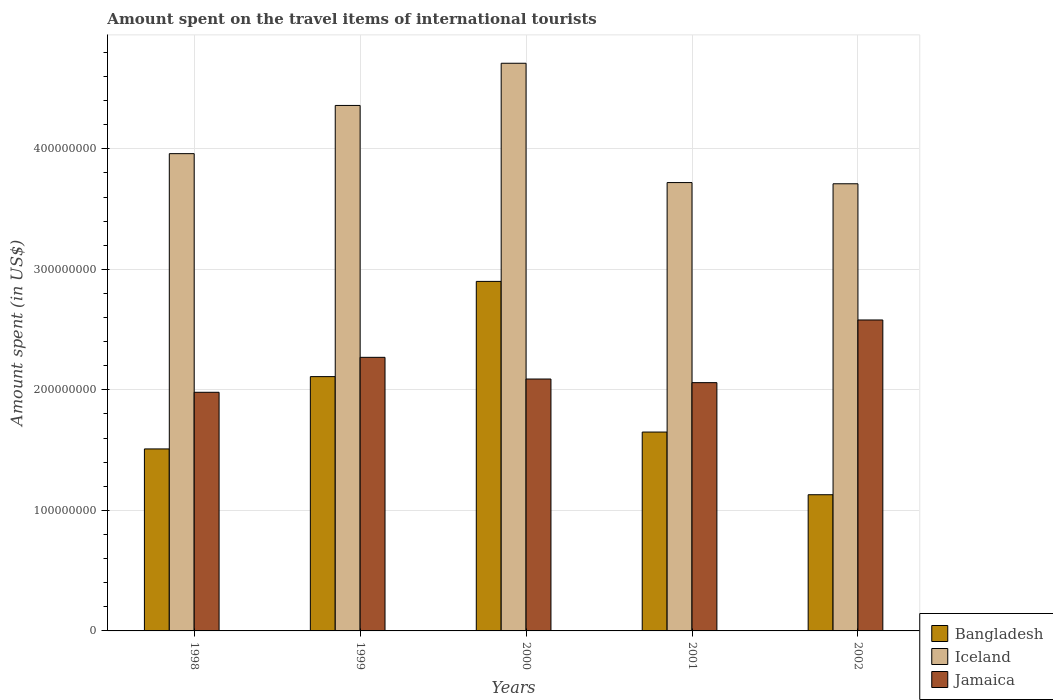How many different coloured bars are there?
Make the answer very short. 3. How many bars are there on the 4th tick from the right?
Provide a short and direct response. 3. What is the amount spent on the travel items of international tourists in Jamaica in 1999?
Give a very brief answer. 2.27e+08. Across all years, what is the maximum amount spent on the travel items of international tourists in Jamaica?
Keep it short and to the point. 2.58e+08. Across all years, what is the minimum amount spent on the travel items of international tourists in Jamaica?
Keep it short and to the point. 1.98e+08. In which year was the amount spent on the travel items of international tourists in Iceland maximum?
Your answer should be very brief. 2000. In which year was the amount spent on the travel items of international tourists in Bangladesh minimum?
Your answer should be very brief. 2002. What is the total amount spent on the travel items of international tourists in Jamaica in the graph?
Provide a short and direct response. 1.10e+09. What is the difference between the amount spent on the travel items of international tourists in Iceland in 2000 and that in 2002?
Keep it short and to the point. 1.00e+08. What is the difference between the amount spent on the travel items of international tourists in Iceland in 1998 and the amount spent on the travel items of international tourists in Jamaica in 1999?
Offer a very short reply. 1.69e+08. What is the average amount spent on the travel items of international tourists in Jamaica per year?
Your answer should be compact. 2.20e+08. In the year 2001, what is the difference between the amount spent on the travel items of international tourists in Bangladesh and amount spent on the travel items of international tourists in Iceland?
Keep it short and to the point. -2.07e+08. What is the ratio of the amount spent on the travel items of international tourists in Iceland in 1998 to that in 1999?
Your response must be concise. 0.91. What is the difference between the highest and the second highest amount spent on the travel items of international tourists in Bangladesh?
Your answer should be compact. 7.90e+07. What is the difference between the highest and the lowest amount spent on the travel items of international tourists in Iceland?
Your response must be concise. 1.00e+08. In how many years, is the amount spent on the travel items of international tourists in Bangladesh greater than the average amount spent on the travel items of international tourists in Bangladesh taken over all years?
Your response must be concise. 2. What does the 3rd bar from the left in 2001 represents?
Offer a very short reply. Jamaica. How many years are there in the graph?
Make the answer very short. 5. How many legend labels are there?
Keep it short and to the point. 3. What is the title of the graph?
Give a very brief answer. Amount spent on the travel items of international tourists. Does "Korea (Democratic)" appear as one of the legend labels in the graph?
Your answer should be compact. No. What is the label or title of the Y-axis?
Provide a succinct answer. Amount spent (in US$). What is the Amount spent (in US$) in Bangladesh in 1998?
Ensure brevity in your answer.  1.51e+08. What is the Amount spent (in US$) in Iceland in 1998?
Your answer should be compact. 3.96e+08. What is the Amount spent (in US$) in Jamaica in 1998?
Offer a terse response. 1.98e+08. What is the Amount spent (in US$) in Bangladesh in 1999?
Keep it short and to the point. 2.11e+08. What is the Amount spent (in US$) in Iceland in 1999?
Your answer should be compact. 4.36e+08. What is the Amount spent (in US$) of Jamaica in 1999?
Provide a short and direct response. 2.27e+08. What is the Amount spent (in US$) of Bangladesh in 2000?
Give a very brief answer. 2.90e+08. What is the Amount spent (in US$) in Iceland in 2000?
Your answer should be very brief. 4.71e+08. What is the Amount spent (in US$) of Jamaica in 2000?
Offer a very short reply. 2.09e+08. What is the Amount spent (in US$) of Bangladesh in 2001?
Provide a short and direct response. 1.65e+08. What is the Amount spent (in US$) of Iceland in 2001?
Keep it short and to the point. 3.72e+08. What is the Amount spent (in US$) of Jamaica in 2001?
Your answer should be compact. 2.06e+08. What is the Amount spent (in US$) in Bangladesh in 2002?
Provide a succinct answer. 1.13e+08. What is the Amount spent (in US$) in Iceland in 2002?
Keep it short and to the point. 3.71e+08. What is the Amount spent (in US$) in Jamaica in 2002?
Give a very brief answer. 2.58e+08. Across all years, what is the maximum Amount spent (in US$) in Bangladesh?
Ensure brevity in your answer.  2.90e+08. Across all years, what is the maximum Amount spent (in US$) in Iceland?
Offer a terse response. 4.71e+08. Across all years, what is the maximum Amount spent (in US$) of Jamaica?
Make the answer very short. 2.58e+08. Across all years, what is the minimum Amount spent (in US$) of Bangladesh?
Your answer should be compact. 1.13e+08. Across all years, what is the minimum Amount spent (in US$) of Iceland?
Offer a terse response. 3.71e+08. Across all years, what is the minimum Amount spent (in US$) of Jamaica?
Keep it short and to the point. 1.98e+08. What is the total Amount spent (in US$) of Bangladesh in the graph?
Offer a very short reply. 9.30e+08. What is the total Amount spent (in US$) in Iceland in the graph?
Offer a terse response. 2.05e+09. What is the total Amount spent (in US$) in Jamaica in the graph?
Keep it short and to the point. 1.10e+09. What is the difference between the Amount spent (in US$) in Bangladesh in 1998 and that in 1999?
Provide a short and direct response. -6.00e+07. What is the difference between the Amount spent (in US$) in Iceland in 1998 and that in 1999?
Provide a succinct answer. -4.00e+07. What is the difference between the Amount spent (in US$) in Jamaica in 1998 and that in 1999?
Your response must be concise. -2.90e+07. What is the difference between the Amount spent (in US$) in Bangladesh in 1998 and that in 2000?
Ensure brevity in your answer.  -1.39e+08. What is the difference between the Amount spent (in US$) of Iceland in 1998 and that in 2000?
Your answer should be compact. -7.50e+07. What is the difference between the Amount spent (in US$) in Jamaica in 1998 and that in 2000?
Offer a terse response. -1.10e+07. What is the difference between the Amount spent (in US$) in Bangladesh in 1998 and that in 2001?
Provide a short and direct response. -1.40e+07. What is the difference between the Amount spent (in US$) of Iceland in 1998 and that in 2001?
Provide a succinct answer. 2.40e+07. What is the difference between the Amount spent (in US$) in Jamaica in 1998 and that in 2001?
Provide a succinct answer. -8.00e+06. What is the difference between the Amount spent (in US$) in Bangladesh in 1998 and that in 2002?
Provide a succinct answer. 3.80e+07. What is the difference between the Amount spent (in US$) of Iceland in 1998 and that in 2002?
Make the answer very short. 2.50e+07. What is the difference between the Amount spent (in US$) in Jamaica in 1998 and that in 2002?
Make the answer very short. -6.00e+07. What is the difference between the Amount spent (in US$) in Bangladesh in 1999 and that in 2000?
Your answer should be compact. -7.90e+07. What is the difference between the Amount spent (in US$) in Iceland in 1999 and that in 2000?
Your answer should be very brief. -3.50e+07. What is the difference between the Amount spent (in US$) in Jamaica in 1999 and that in 2000?
Offer a very short reply. 1.80e+07. What is the difference between the Amount spent (in US$) of Bangladesh in 1999 and that in 2001?
Keep it short and to the point. 4.60e+07. What is the difference between the Amount spent (in US$) of Iceland in 1999 and that in 2001?
Give a very brief answer. 6.40e+07. What is the difference between the Amount spent (in US$) of Jamaica in 1999 and that in 2001?
Keep it short and to the point. 2.10e+07. What is the difference between the Amount spent (in US$) in Bangladesh in 1999 and that in 2002?
Your answer should be compact. 9.80e+07. What is the difference between the Amount spent (in US$) of Iceland in 1999 and that in 2002?
Make the answer very short. 6.50e+07. What is the difference between the Amount spent (in US$) of Jamaica in 1999 and that in 2002?
Give a very brief answer. -3.10e+07. What is the difference between the Amount spent (in US$) of Bangladesh in 2000 and that in 2001?
Your answer should be very brief. 1.25e+08. What is the difference between the Amount spent (in US$) of Iceland in 2000 and that in 2001?
Provide a succinct answer. 9.90e+07. What is the difference between the Amount spent (in US$) of Jamaica in 2000 and that in 2001?
Make the answer very short. 3.00e+06. What is the difference between the Amount spent (in US$) of Bangladesh in 2000 and that in 2002?
Your answer should be compact. 1.77e+08. What is the difference between the Amount spent (in US$) of Iceland in 2000 and that in 2002?
Keep it short and to the point. 1.00e+08. What is the difference between the Amount spent (in US$) of Jamaica in 2000 and that in 2002?
Offer a terse response. -4.90e+07. What is the difference between the Amount spent (in US$) of Bangladesh in 2001 and that in 2002?
Keep it short and to the point. 5.20e+07. What is the difference between the Amount spent (in US$) of Jamaica in 2001 and that in 2002?
Your answer should be very brief. -5.20e+07. What is the difference between the Amount spent (in US$) in Bangladesh in 1998 and the Amount spent (in US$) in Iceland in 1999?
Your answer should be compact. -2.85e+08. What is the difference between the Amount spent (in US$) of Bangladesh in 1998 and the Amount spent (in US$) of Jamaica in 1999?
Ensure brevity in your answer.  -7.60e+07. What is the difference between the Amount spent (in US$) of Iceland in 1998 and the Amount spent (in US$) of Jamaica in 1999?
Give a very brief answer. 1.69e+08. What is the difference between the Amount spent (in US$) in Bangladesh in 1998 and the Amount spent (in US$) in Iceland in 2000?
Offer a terse response. -3.20e+08. What is the difference between the Amount spent (in US$) in Bangladesh in 1998 and the Amount spent (in US$) in Jamaica in 2000?
Make the answer very short. -5.80e+07. What is the difference between the Amount spent (in US$) in Iceland in 1998 and the Amount spent (in US$) in Jamaica in 2000?
Provide a short and direct response. 1.87e+08. What is the difference between the Amount spent (in US$) of Bangladesh in 1998 and the Amount spent (in US$) of Iceland in 2001?
Offer a terse response. -2.21e+08. What is the difference between the Amount spent (in US$) in Bangladesh in 1998 and the Amount spent (in US$) in Jamaica in 2001?
Offer a terse response. -5.50e+07. What is the difference between the Amount spent (in US$) of Iceland in 1998 and the Amount spent (in US$) of Jamaica in 2001?
Give a very brief answer. 1.90e+08. What is the difference between the Amount spent (in US$) of Bangladesh in 1998 and the Amount spent (in US$) of Iceland in 2002?
Your answer should be very brief. -2.20e+08. What is the difference between the Amount spent (in US$) in Bangladesh in 1998 and the Amount spent (in US$) in Jamaica in 2002?
Offer a terse response. -1.07e+08. What is the difference between the Amount spent (in US$) in Iceland in 1998 and the Amount spent (in US$) in Jamaica in 2002?
Your answer should be very brief. 1.38e+08. What is the difference between the Amount spent (in US$) of Bangladesh in 1999 and the Amount spent (in US$) of Iceland in 2000?
Ensure brevity in your answer.  -2.60e+08. What is the difference between the Amount spent (in US$) in Bangladesh in 1999 and the Amount spent (in US$) in Jamaica in 2000?
Give a very brief answer. 2.00e+06. What is the difference between the Amount spent (in US$) in Iceland in 1999 and the Amount spent (in US$) in Jamaica in 2000?
Offer a terse response. 2.27e+08. What is the difference between the Amount spent (in US$) in Bangladesh in 1999 and the Amount spent (in US$) in Iceland in 2001?
Provide a succinct answer. -1.61e+08. What is the difference between the Amount spent (in US$) in Bangladesh in 1999 and the Amount spent (in US$) in Jamaica in 2001?
Give a very brief answer. 5.00e+06. What is the difference between the Amount spent (in US$) in Iceland in 1999 and the Amount spent (in US$) in Jamaica in 2001?
Make the answer very short. 2.30e+08. What is the difference between the Amount spent (in US$) of Bangladesh in 1999 and the Amount spent (in US$) of Iceland in 2002?
Give a very brief answer. -1.60e+08. What is the difference between the Amount spent (in US$) in Bangladesh in 1999 and the Amount spent (in US$) in Jamaica in 2002?
Offer a very short reply. -4.70e+07. What is the difference between the Amount spent (in US$) in Iceland in 1999 and the Amount spent (in US$) in Jamaica in 2002?
Provide a short and direct response. 1.78e+08. What is the difference between the Amount spent (in US$) in Bangladesh in 2000 and the Amount spent (in US$) in Iceland in 2001?
Make the answer very short. -8.20e+07. What is the difference between the Amount spent (in US$) of Bangladesh in 2000 and the Amount spent (in US$) of Jamaica in 2001?
Your answer should be very brief. 8.40e+07. What is the difference between the Amount spent (in US$) in Iceland in 2000 and the Amount spent (in US$) in Jamaica in 2001?
Provide a succinct answer. 2.65e+08. What is the difference between the Amount spent (in US$) in Bangladesh in 2000 and the Amount spent (in US$) in Iceland in 2002?
Ensure brevity in your answer.  -8.10e+07. What is the difference between the Amount spent (in US$) in Bangladesh in 2000 and the Amount spent (in US$) in Jamaica in 2002?
Ensure brevity in your answer.  3.20e+07. What is the difference between the Amount spent (in US$) in Iceland in 2000 and the Amount spent (in US$) in Jamaica in 2002?
Keep it short and to the point. 2.13e+08. What is the difference between the Amount spent (in US$) in Bangladesh in 2001 and the Amount spent (in US$) in Iceland in 2002?
Your answer should be compact. -2.06e+08. What is the difference between the Amount spent (in US$) in Bangladesh in 2001 and the Amount spent (in US$) in Jamaica in 2002?
Your answer should be compact. -9.30e+07. What is the difference between the Amount spent (in US$) of Iceland in 2001 and the Amount spent (in US$) of Jamaica in 2002?
Your answer should be compact. 1.14e+08. What is the average Amount spent (in US$) of Bangladesh per year?
Give a very brief answer. 1.86e+08. What is the average Amount spent (in US$) in Iceland per year?
Ensure brevity in your answer.  4.09e+08. What is the average Amount spent (in US$) in Jamaica per year?
Your response must be concise. 2.20e+08. In the year 1998, what is the difference between the Amount spent (in US$) of Bangladesh and Amount spent (in US$) of Iceland?
Make the answer very short. -2.45e+08. In the year 1998, what is the difference between the Amount spent (in US$) of Bangladesh and Amount spent (in US$) of Jamaica?
Make the answer very short. -4.70e+07. In the year 1998, what is the difference between the Amount spent (in US$) in Iceland and Amount spent (in US$) in Jamaica?
Give a very brief answer. 1.98e+08. In the year 1999, what is the difference between the Amount spent (in US$) in Bangladesh and Amount spent (in US$) in Iceland?
Your answer should be compact. -2.25e+08. In the year 1999, what is the difference between the Amount spent (in US$) in Bangladesh and Amount spent (in US$) in Jamaica?
Provide a succinct answer. -1.60e+07. In the year 1999, what is the difference between the Amount spent (in US$) of Iceland and Amount spent (in US$) of Jamaica?
Your response must be concise. 2.09e+08. In the year 2000, what is the difference between the Amount spent (in US$) in Bangladesh and Amount spent (in US$) in Iceland?
Ensure brevity in your answer.  -1.81e+08. In the year 2000, what is the difference between the Amount spent (in US$) in Bangladesh and Amount spent (in US$) in Jamaica?
Ensure brevity in your answer.  8.10e+07. In the year 2000, what is the difference between the Amount spent (in US$) in Iceland and Amount spent (in US$) in Jamaica?
Offer a terse response. 2.62e+08. In the year 2001, what is the difference between the Amount spent (in US$) of Bangladesh and Amount spent (in US$) of Iceland?
Ensure brevity in your answer.  -2.07e+08. In the year 2001, what is the difference between the Amount spent (in US$) in Bangladesh and Amount spent (in US$) in Jamaica?
Your answer should be compact. -4.10e+07. In the year 2001, what is the difference between the Amount spent (in US$) in Iceland and Amount spent (in US$) in Jamaica?
Make the answer very short. 1.66e+08. In the year 2002, what is the difference between the Amount spent (in US$) of Bangladesh and Amount spent (in US$) of Iceland?
Your response must be concise. -2.58e+08. In the year 2002, what is the difference between the Amount spent (in US$) in Bangladesh and Amount spent (in US$) in Jamaica?
Your response must be concise. -1.45e+08. In the year 2002, what is the difference between the Amount spent (in US$) of Iceland and Amount spent (in US$) of Jamaica?
Provide a succinct answer. 1.13e+08. What is the ratio of the Amount spent (in US$) of Bangladesh in 1998 to that in 1999?
Offer a very short reply. 0.72. What is the ratio of the Amount spent (in US$) of Iceland in 1998 to that in 1999?
Make the answer very short. 0.91. What is the ratio of the Amount spent (in US$) of Jamaica in 1998 to that in 1999?
Provide a short and direct response. 0.87. What is the ratio of the Amount spent (in US$) in Bangladesh in 1998 to that in 2000?
Provide a succinct answer. 0.52. What is the ratio of the Amount spent (in US$) of Iceland in 1998 to that in 2000?
Your answer should be very brief. 0.84. What is the ratio of the Amount spent (in US$) in Jamaica in 1998 to that in 2000?
Keep it short and to the point. 0.95. What is the ratio of the Amount spent (in US$) of Bangladesh in 1998 to that in 2001?
Provide a short and direct response. 0.92. What is the ratio of the Amount spent (in US$) of Iceland in 1998 to that in 2001?
Your answer should be compact. 1.06. What is the ratio of the Amount spent (in US$) in Jamaica in 1998 to that in 2001?
Offer a very short reply. 0.96. What is the ratio of the Amount spent (in US$) of Bangladesh in 1998 to that in 2002?
Your answer should be very brief. 1.34. What is the ratio of the Amount spent (in US$) of Iceland in 1998 to that in 2002?
Ensure brevity in your answer.  1.07. What is the ratio of the Amount spent (in US$) of Jamaica in 1998 to that in 2002?
Keep it short and to the point. 0.77. What is the ratio of the Amount spent (in US$) of Bangladesh in 1999 to that in 2000?
Keep it short and to the point. 0.73. What is the ratio of the Amount spent (in US$) in Iceland in 1999 to that in 2000?
Your answer should be very brief. 0.93. What is the ratio of the Amount spent (in US$) in Jamaica in 1999 to that in 2000?
Ensure brevity in your answer.  1.09. What is the ratio of the Amount spent (in US$) of Bangladesh in 1999 to that in 2001?
Provide a short and direct response. 1.28. What is the ratio of the Amount spent (in US$) in Iceland in 1999 to that in 2001?
Offer a very short reply. 1.17. What is the ratio of the Amount spent (in US$) in Jamaica in 1999 to that in 2001?
Your answer should be compact. 1.1. What is the ratio of the Amount spent (in US$) in Bangladesh in 1999 to that in 2002?
Give a very brief answer. 1.87. What is the ratio of the Amount spent (in US$) in Iceland in 1999 to that in 2002?
Provide a succinct answer. 1.18. What is the ratio of the Amount spent (in US$) in Jamaica in 1999 to that in 2002?
Offer a very short reply. 0.88. What is the ratio of the Amount spent (in US$) in Bangladesh in 2000 to that in 2001?
Your answer should be very brief. 1.76. What is the ratio of the Amount spent (in US$) in Iceland in 2000 to that in 2001?
Your answer should be very brief. 1.27. What is the ratio of the Amount spent (in US$) in Jamaica in 2000 to that in 2001?
Offer a terse response. 1.01. What is the ratio of the Amount spent (in US$) in Bangladesh in 2000 to that in 2002?
Provide a succinct answer. 2.57. What is the ratio of the Amount spent (in US$) in Iceland in 2000 to that in 2002?
Offer a terse response. 1.27. What is the ratio of the Amount spent (in US$) of Jamaica in 2000 to that in 2002?
Your response must be concise. 0.81. What is the ratio of the Amount spent (in US$) in Bangladesh in 2001 to that in 2002?
Offer a terse response. 1.46. What is the ratio of the Amount spent (in US$) in Jamaica in 2001 to that in 2002?
Your answer should be compact. 0.8. What is the difference between the highest and the second highest Amount spent (in US$) of Bangladesh?
Provide a succinct answer. 7.90e+07. What is the difference between the highest and the second highest Amount spent (in US$) of Iceland?
Offer a very short reply. 3.50e+07. What is the difference between the highest and the second highest Amount spent (in US$) of Jamaica?
Provide a succinct answer. 3.10e+07. What is the difference between the highest and the lowest Amount spent (in US$) of Bangladesh?
Your response must be concise. 1.77e+08. What is the difference between the highest and the lowest Amount spent (in US$) in Iceland?
Make the answer very short. 1.00e+08. What is the difference between the highest and the lowest Amount spent (in US$) of Jamaica?
Your response must be concise. 6.00e+07. 